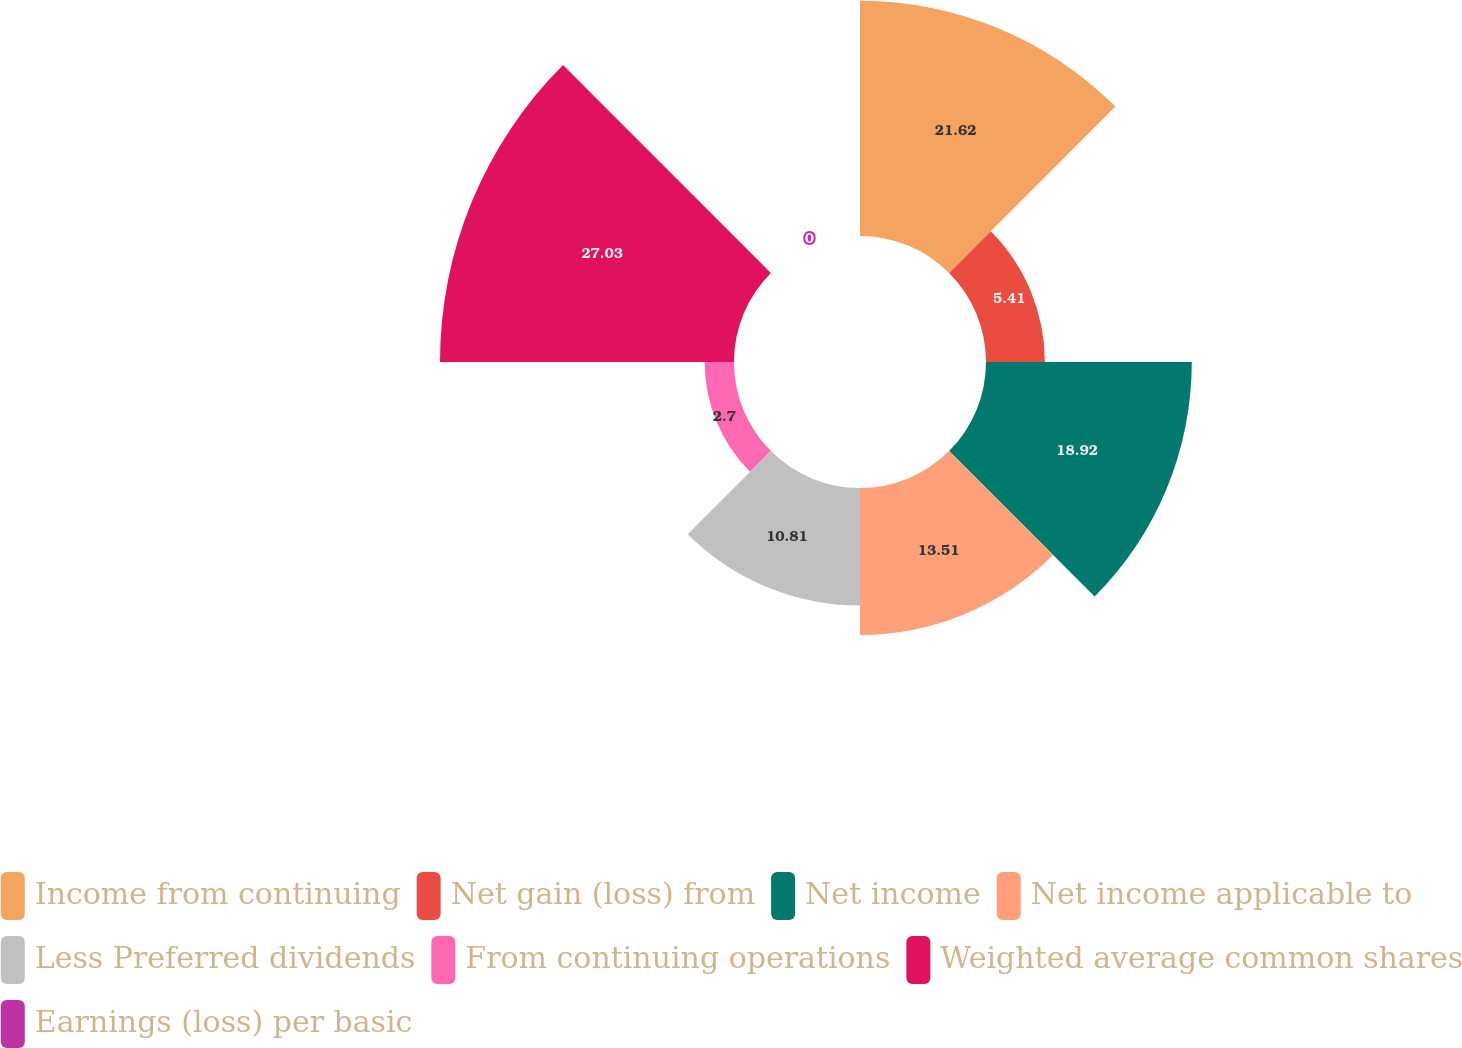Convert chart. <chart><loc_0><loc_0><loc_500><loc_500><pie_chart><fcel>Income from continuing<fcel>Net gain (loss) from<fcel>Net income<fcel>Net income applicable to<fcel>Less Preferred dividends<fcel>From continuing operations<fcel>Weighted average common shares<fcel>Earnings (loss) per basic<nl><fcel>21.62%<fcel>5.41%<fcel>18.92%<fcel>13.51%<fcel>10.81%<fcel>2.7%<fcel>27.03%<fcel>0.0%<nl></chart> 